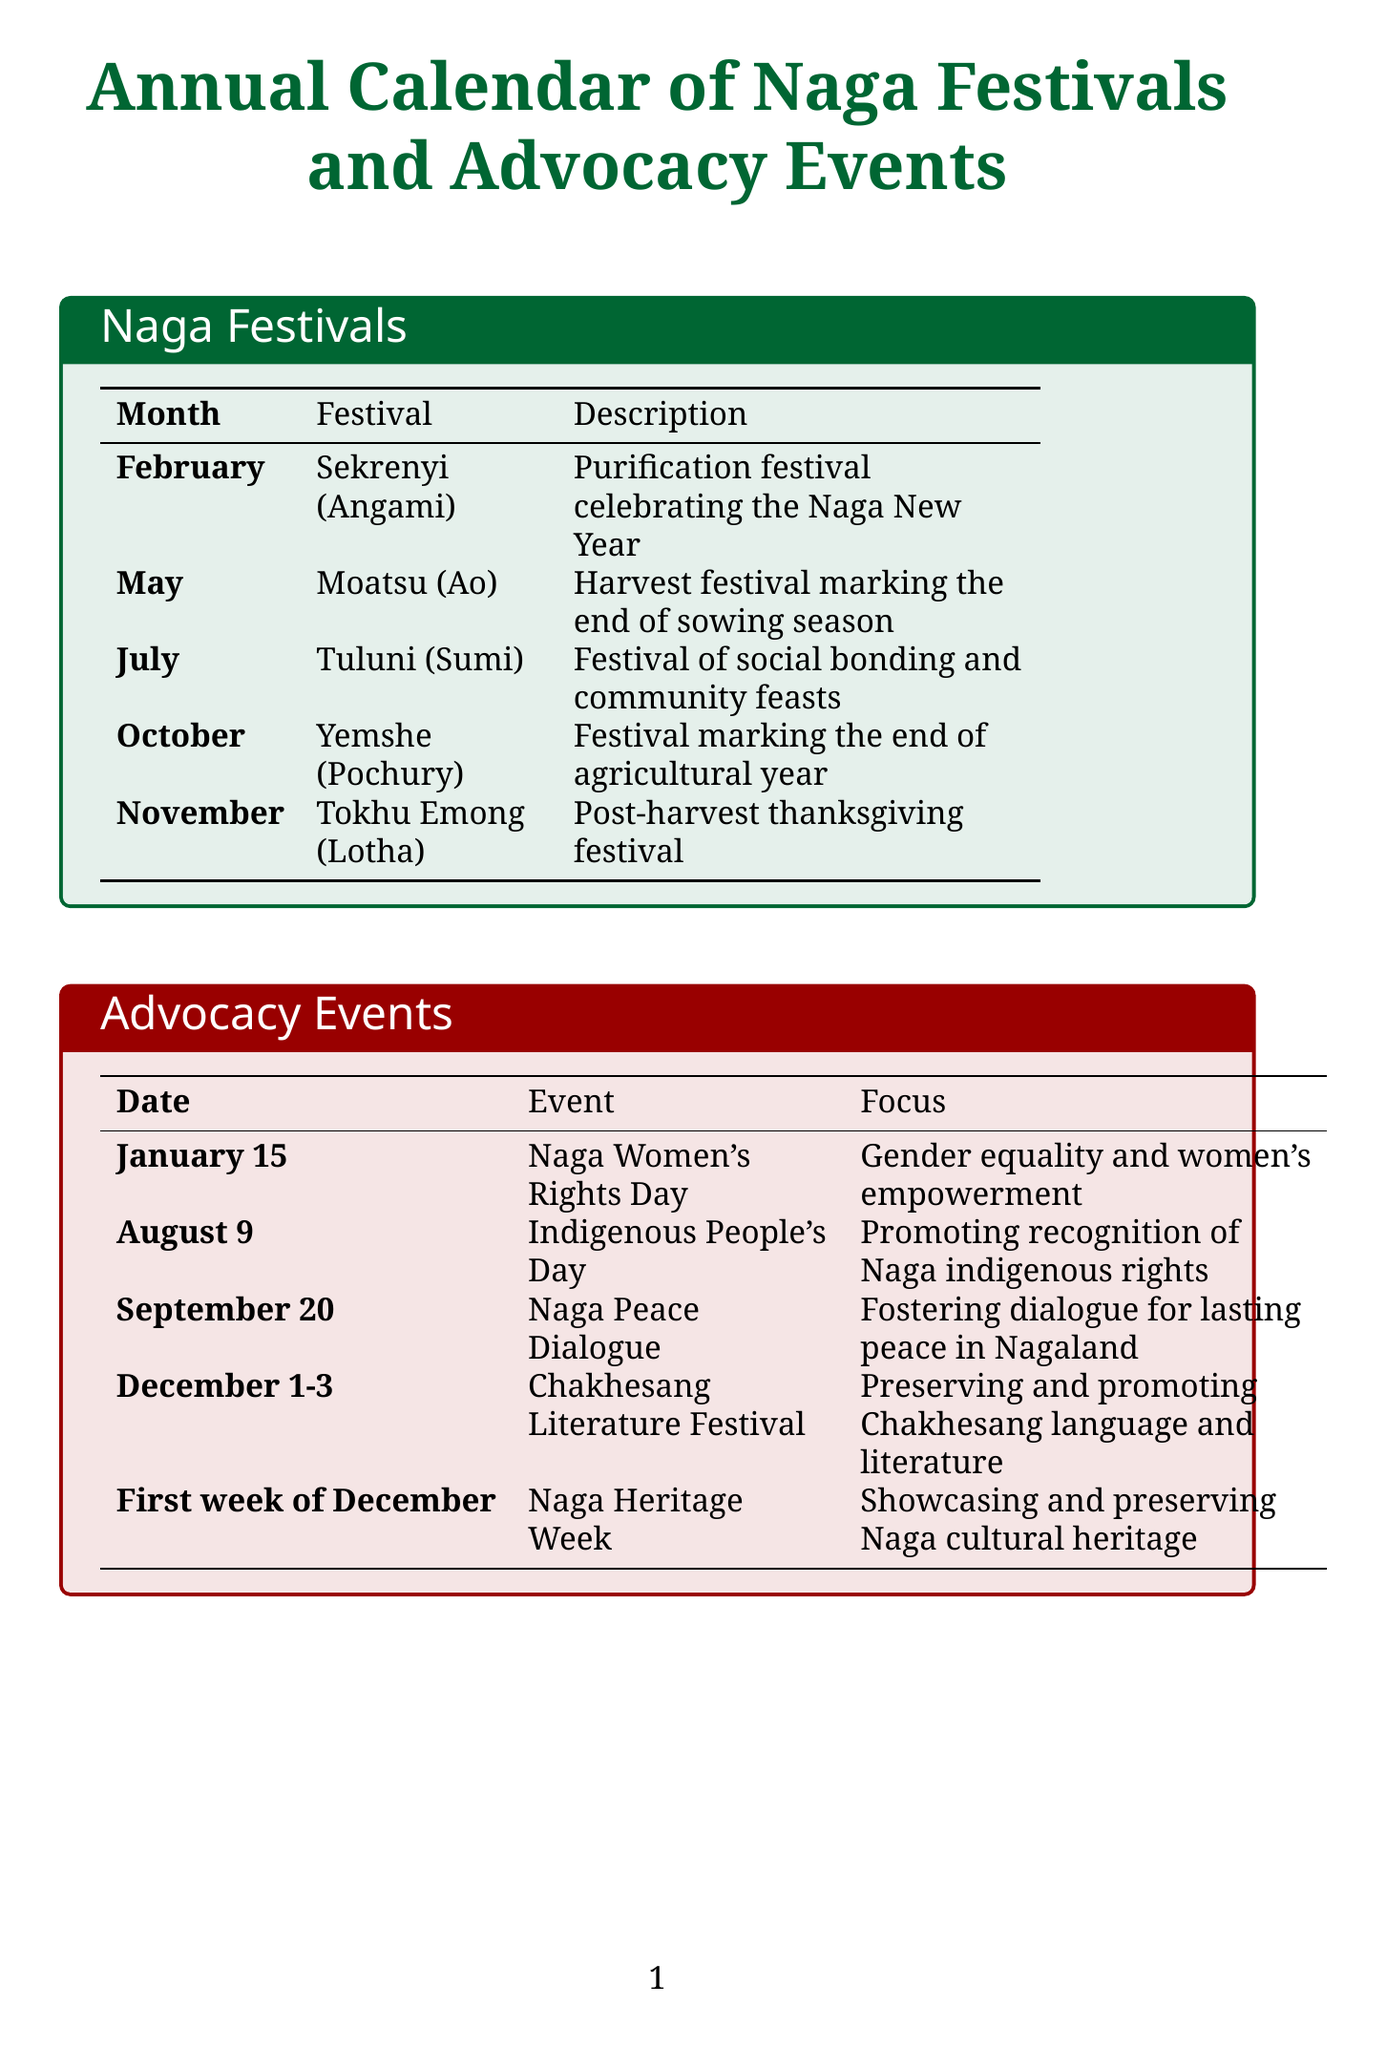What is the first festival listed in the document? The first festival is Sekrenyi, which appears at the top of the festival list.
Answer: Sekrenyi Which tribe celebrates the Moatsu festival? The Moatsu festival is celebrated by the Ao Naga tribe, as stated in the festival details.
Answer: Ao Naga What advocacy event occurs on January 15? The event on January 15 is Naga Women's Rights Day, as listed in the advocacy events section.
Answer: Naga Women's Rights Day In which month is Yemshe celebrated? Yemshe is celebrated in October, according to the festival schedule.
Answer: October How many festivals are listed in the document? There are five festivals mentioned in the document's festival section.
Answer: Five What is the focus of the Naga Women Entrepreneurs' Meet? The focus of the Naga Women Entrepreneurs' Meet is on empowering Naga women in business and social entrepreneurship.
Answer: Empowering Naga women in business and social entrepreneurship Which festival is associated with environmental conservation? The Tokhu Emong festival focuses on environmental conservation and traditional knowledge, as noted in its advocacy focus.
Answer: Tokhu Emong When is the Chizami Women’s Day celebrated? Chizami Women’s Day is celebrated on March 8, as stated in Seno Tsuhah's initiatives.
Answer: March 8 What is the frequency of the Sustainable Living Workshop Series? The Sustainable Living Workshop Series is listed as a quarterly event in the initiatives section.
Answer: Quarterly 